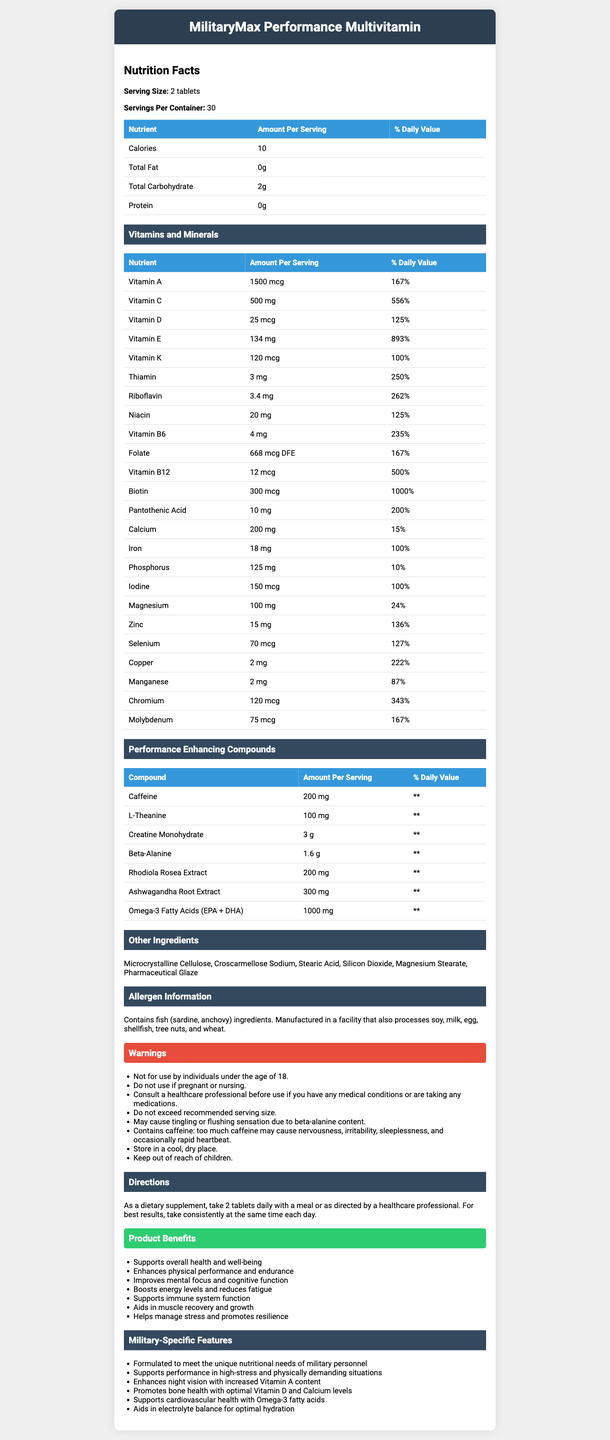what is the serving size of the MilitaryMax Performance Multivitamin? The serving size is clearly stated on the document as 2 tablets.
Answer: 2 tablets how many servings per container are there? The document indicates that there are 30 servings per container.
Answer: 30 how many calories are in one serving of the supplement? According to the document, each serving contains 10 calories.
Answer: 10 which vitamin is present in the highest percentage of the daily value? The document lists Vitamin E as having 134 mg, which is 893% of the daily value, the highest percentage among the vitamins and minerals.
Answer: Vitamin E how much caffeine is present in one serving of the supplement? The table under "Performance Enhancing Compounds" shows that there is 200 mg of caffeine per serving.
Answer: 200 mg which of the following compounds is not included in the performance-enhancing compounds? A. Caffeine B. L-Theanine C. Protein D. Omega-3 Fatty Acids The document lists Caffeine, L-Theanine, and Omega-3 Fatty Acids among the performance-enhancing compounds, but Protein is not included in that list.
Answer: C. Protein which vitamin listed has a daily value of over 800%? A. Vitamin A B. Vitamin D C. Vitamin E D. Vitamin K The document shows that Vitamin E has a daily value of 893%, which is over 800%.
Answer: C. Vitamin E is this supplement suitable for individuals under the age of 18? The warning section clearly states, "Not for use by individuals under the age of 18."
Answer: No describe the main purposes of the MilitaryMax Performance Multivitamin supplement. The document outlines these benefits under the section titled "Product Benefits" and "Military-Specific Features," which detail how the supplement is tailored for the needs of military personnel.
Answer: The main purposes are to support overall health and well-being, enhance physical performance and endurance, improve mental focus and cognitive function, boost energy levels and reduce fatigue, support immune system function, aid in muscle recovery and growth, and help manage stress and promote resilience. why might someone feel a tingling or flushing sensation after taking the supplement? The warnings section mentions that the supplement "may cause tingling or flushing sensation due to beta-alanine content."
Answer: Due to the beta-alanine content. can the daily value of L-Theanine be determined from the document? The document indicates that the daily value of L-Theanine is ** (not available), so we cannot determine its daily value from the visual information.
Answer: No what are the directions for taking this supplement? The document provides these instructions under the section "Directions."
Answer: Take 2 tablets daily with a meal or as directed by a healthcare professional. For best results, take consistently at the same time each day. which ingredients are mentioned as potential allergens? The allergen information section specifies these allergens and mentions that the product is manufactured in a facility that processes these ingredients.
Answer: Fish (sardine, anchovy); soy, milk, egg, shellfish, tree nuts, and wheat. what are the other ingredients in the supplement? These ingredients are listed under the "Other Ingredients" section in the document.
Answer: Microcrystalline Cellulose, Croscarmellose Sodium, Stearic Acid, Silicon Dioxide, Magnesium Stearate, Pharmaceutical Glaze 